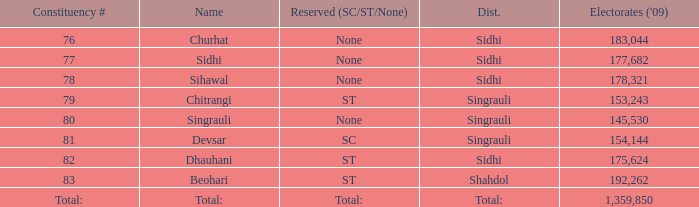What is the district with 79 constituency number? Singrauli. 